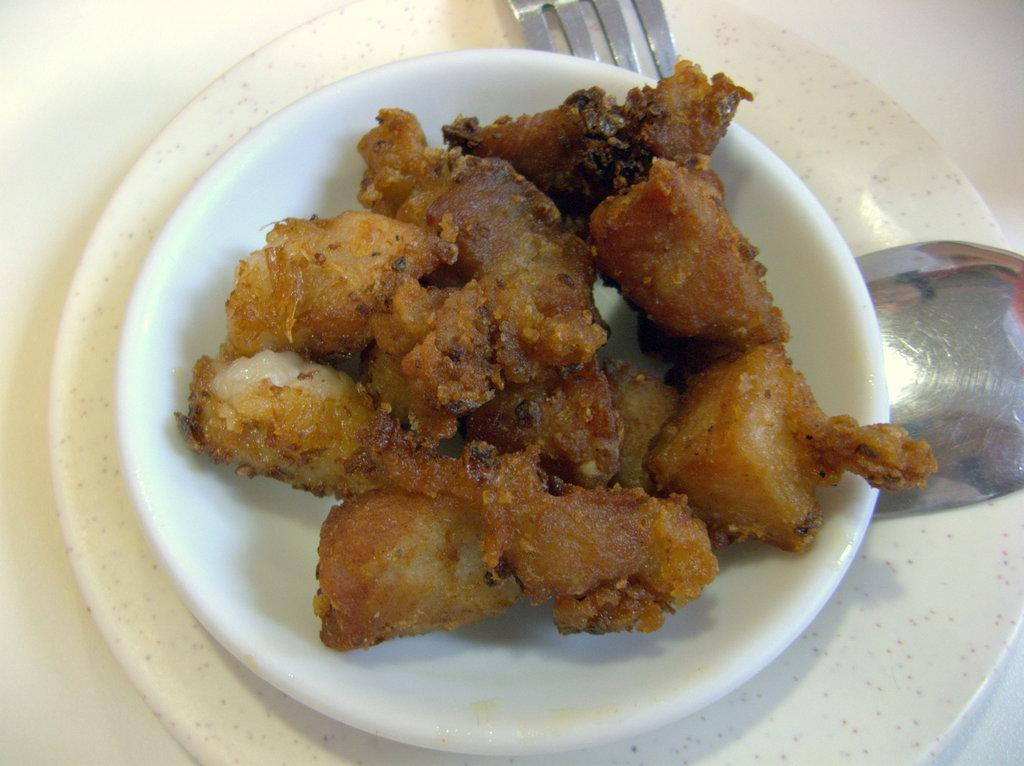What can be seen in the image related to food? There is food in the image. What objects are present for eating the food? There are plates, spoons, and forks in the image. What is the color of the platform in the image? The platform is white in color. What type of fuel is being used to power the circle in the image? There is no circle or fuel present in the image. 